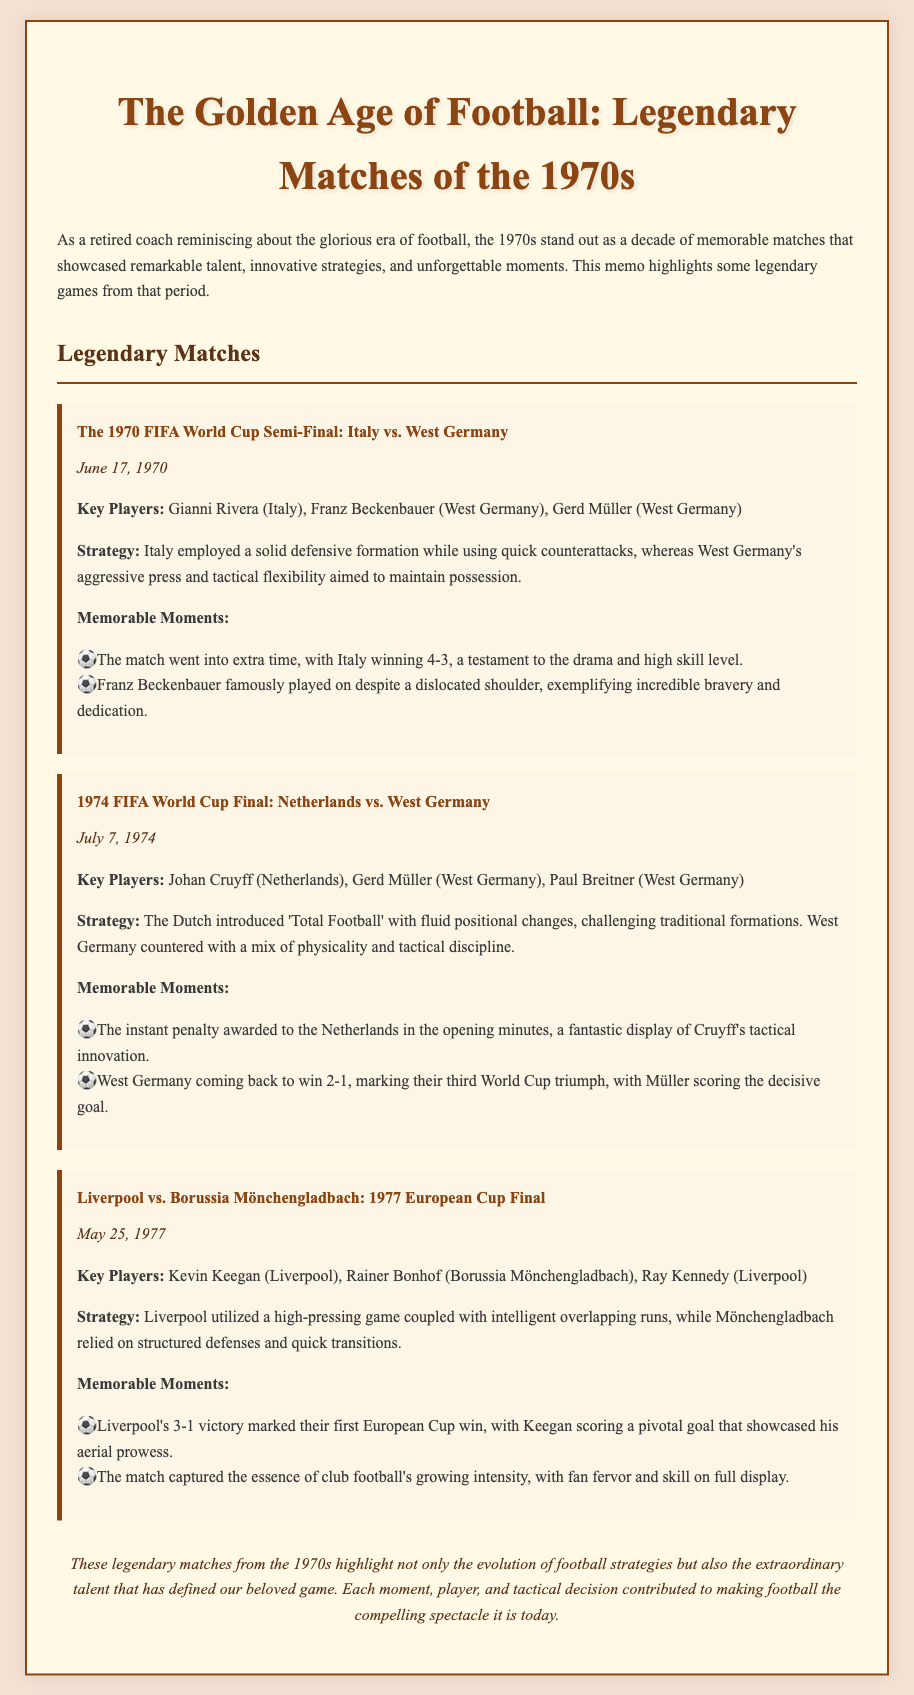What was the date of the Italy vs. West Germany match? The date of the match is stated in the document as June 17, 1970.
Answer: June 17, 1970 Who scored the decisive goal for West Germany in the 1974 FIFA World Cup Final? The document notes that Gerd Müller scored the decisive goal for West Germany.
Answer: Gerd Müller What was the score in the Liverpool vs. Borussia Mönchengladbach final? The document mentions that Liverpool won the match with a score of 3-1.
Answer: 3-1 Which strategy did the Netherlands introduce during the 1974 final? The document states that the Dutch introduced 'Total Football' as their strategy.
Answer: Total Football What notable injury did Franz Beckenbauer sustain during the 1970 semi-final? The memo highlights that Franz Beckenbauer dislocated his shoulder in that match.
Answer: Dislocated shoulder How many World Cups had West Germany won after their victory in 1974? The document indicates that their win in 1974 marked West Germany's third World Cup triumph.
Answer: Three What was a key feature of Liverpool's strategy in the 1977 European Cup Final? The memo describes Liverpool's strategy as utilizing a high-pressing game coupled with intelligent overlapping runs.
Answer: High-pressing game What memorable moment occurred at the beginning of the 1974 World Cup Final? The document states that a penalty was awarded to the Netherlands in the opening minutes of the match.
Answer: Instant penalty In which year did the Liverpool vs. Borussia Mönchengladbach match take place? The date is specified in the document as May 25, 1977.
Answer: May 25, 1977 